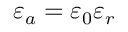<formula> <loc_0><loc_0><loc_500><loc_500>\varepsilon _ { a } = \varepsilon _ { 0 } \varepsilon _ { r }</formula> 